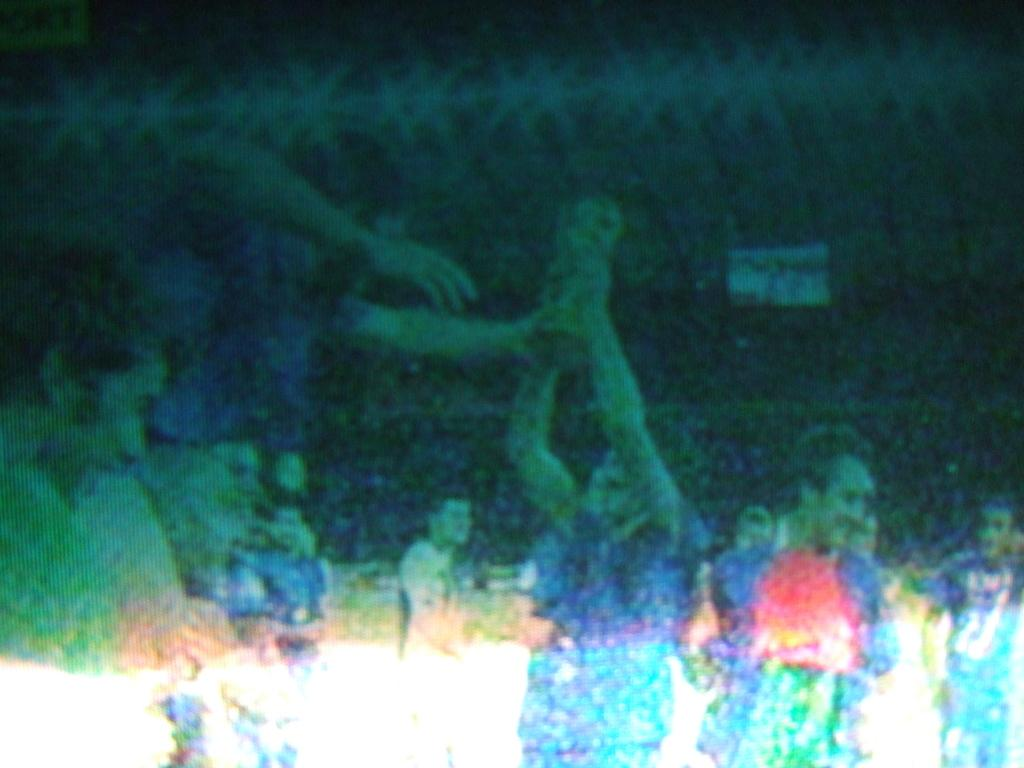How many people are in the picture? The number of people in the picture cannot be determined from the given fact. What type of clock is visible in the picture? There is no clock present in the picture, as only the presence of people is mentioned in the fact. 